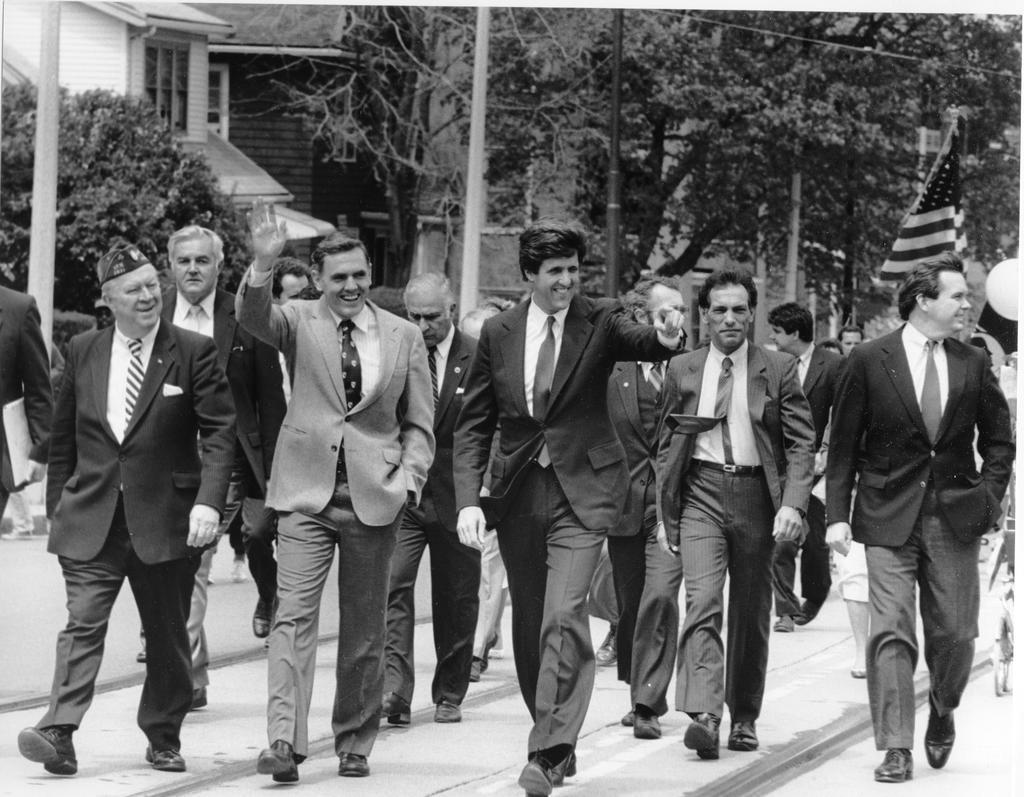Can you describe this image briefly? In this image we can see many people are walking on the road and one flag is there. There are some trees, buildings and poles. Some people are holding some objects, one person waving his hand. 